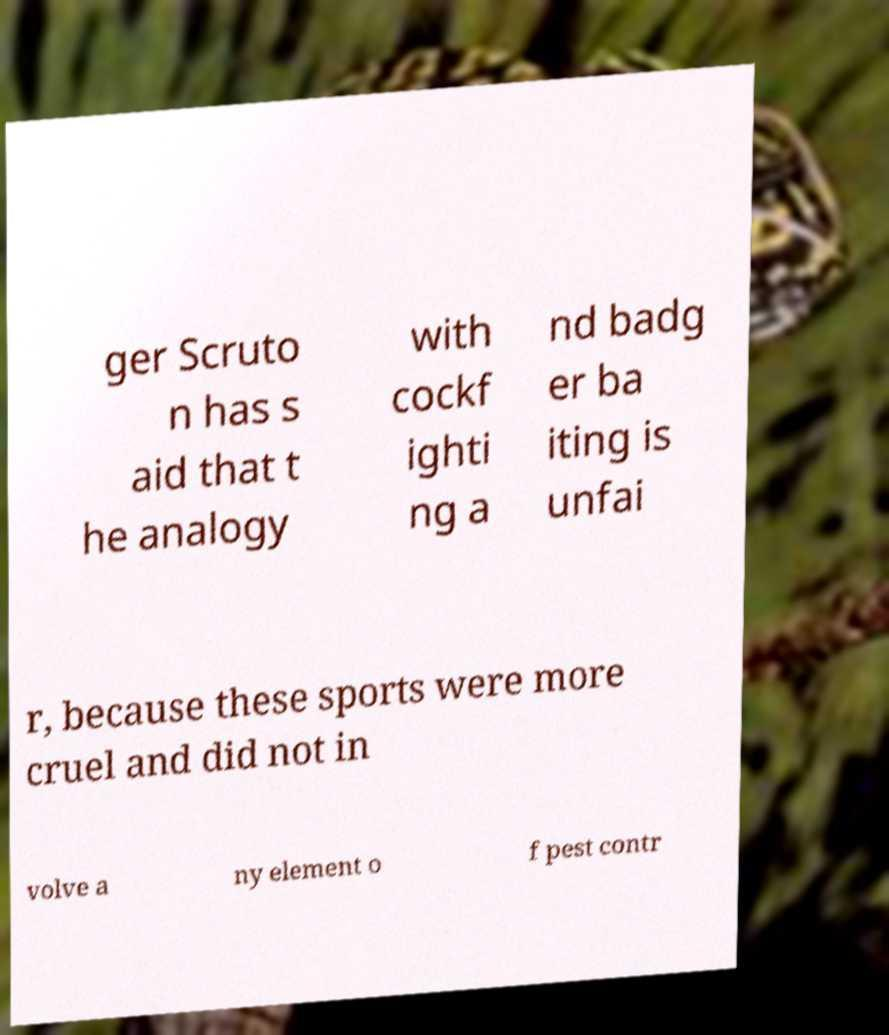Could you assist in decoding the text presented in this image and type it out clearly? ger Scruto n has s aid that t he analogy with cockf ighti ng a nd badg er ba iting is unfai r, because these sports were more cruel and did not in volve a ny element o f pest contr 